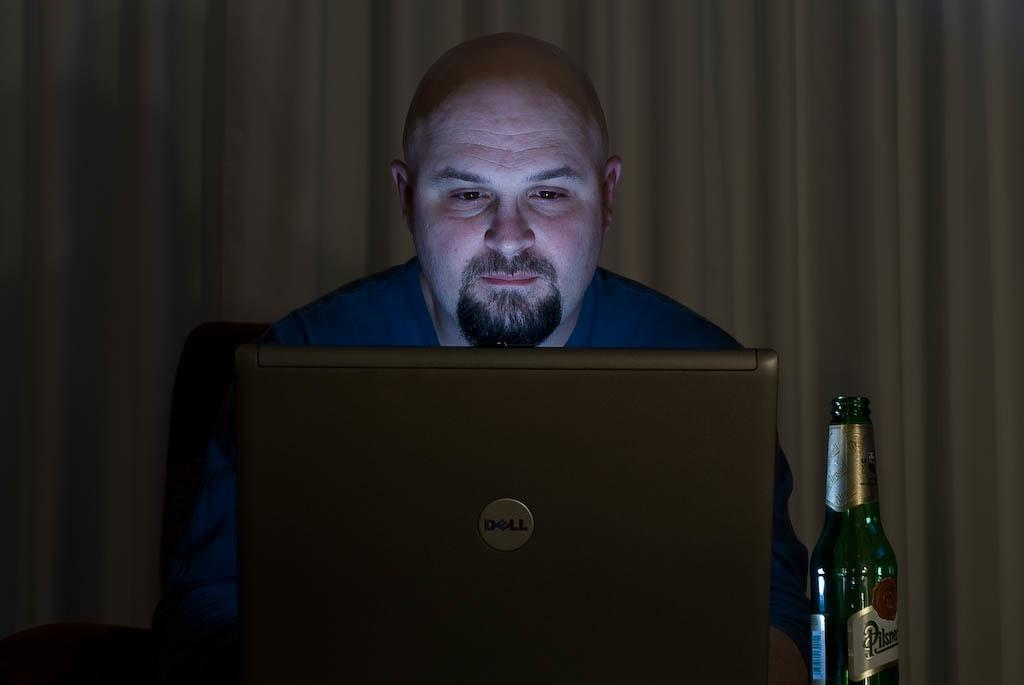What is the man in the image doing? The man is sitting on a chair in the image. What object is visible on the table or surface in front of the man? There is a laptop in the image. What is the man holding in his hand? There is a bottle in the image. What can be seen in the background of the image? There are curtains visible in the background of the image. What type of bed is present in the image? There is no bed present in the image. 